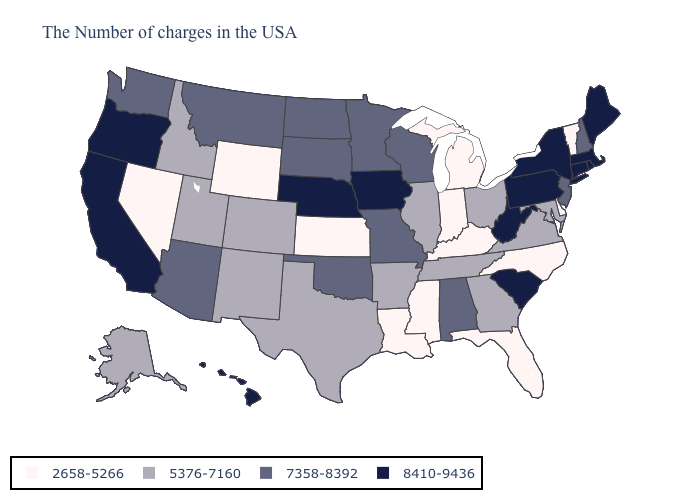Name the states that have a value in the range 2658-5266?
Keep it brief. Vermont, Delaware, North Carolina, Florida, Michigan, Kentucky, Indiana, Mississippi, Louisiana, Kansas, Wyoming, Nevada. Does Connecticut have a higher value than Rhode Island?
Concise answer only. No. Name the states that have a value in the range 7358-8392?
Be succinct. New Hampshire, New Jersey, Alabama, Wisconsin, Missouri, Minnesota, Oklahoma, South Dakota, North Dakota, Montana, Arizona, Washington. What is the value of Wisconsin?
Quick response, please. 7358-8392. What is the highest value in states that border New Hampshire?
Concise answer only. 8410-9436. Which states have the lowest value in the USA?
Quick response, please. Vermont, Delaware, North Carolina, Florida, Michigan, Kentucky, Indiana, Mississippi, Louisiana, Kansas, Wyoming, Nevada. What is the highest value in states that border Mississippi?
Give a very brief answer. 7358-8392. Among the states that border Minnesota , which have the lowest value?
Short answer required. Wisconsin, South Dakota, North Dakota. What is the highest value in the West ?
Write a very short answer. 8410-9436. Does Connecticut have the lowest value in the Northeast?
Write a very short answer. No. Among the states that border Massachusetts , which have the highest value?
Quick response, please. Rhode Island, Connecticut, New York. What is the highest value in the MidWest ?
Give a very brief answer. 8410-9436. Name the states that have a value in the range 2658-5266?
Short answer required. Vermont, Delaware, North Carolina, Florida, Michigan, Kentucky, Indiana, Mississippi, Louisiana, Kansas, Wyoming, Nevada. Does Virginia have a lower value than South Dakota?
Concise answer only. Yes. What is the value of Louisiana?
Answer briefly. 2658-5266. 